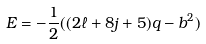Convert formula to latex. <formula><loc_0><loc_0><loc_500><loc_500>E = - \frac { 1 } { 2 } ( ( 2 \ell + 8 j + 5 ) q - b ^ { 2 } )</formula> 